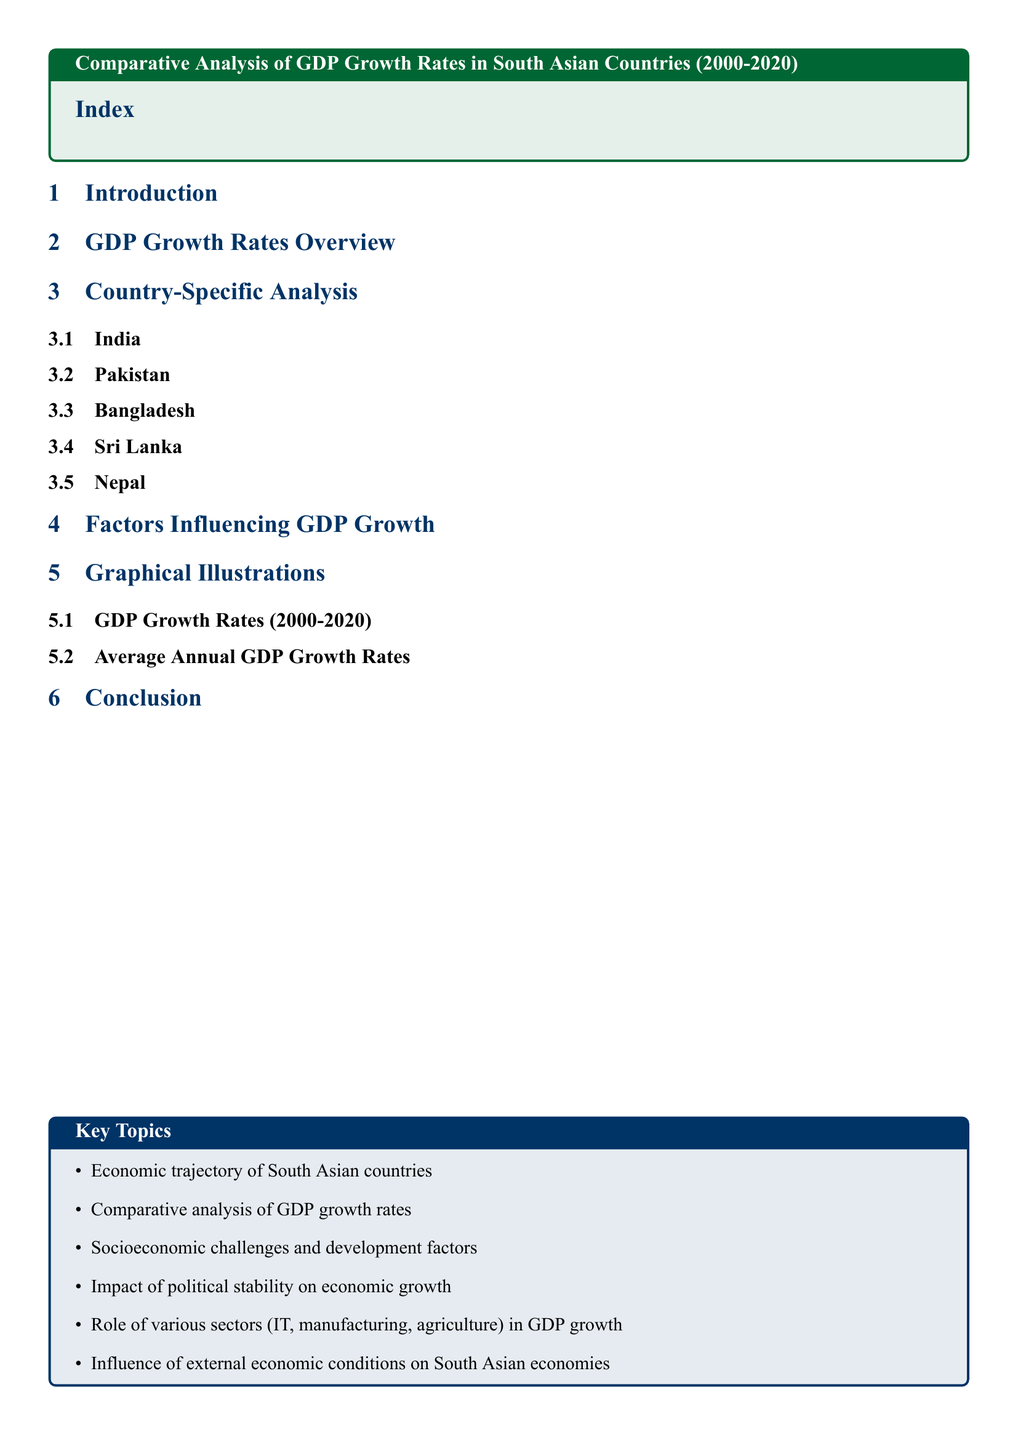What years are covered in the GDP analysis? The document analyzes GDP growth rates from the years 2000 to 2020.
Answer: 2000-2020 How many countries are specifically analyzed in the document? The document specifies the GDP growth analysis for five countries in South Asia.
Answer: Five Which country has its own subsection in the analysis? The document includes individual subsections for multiple countries, such as India, which is one of them.
Answer: India What is one of the key topics mentioned in the document? The document lists key topics at the end, one of which is "Comparison of GDP growth rates."
Answer: Comparison of GDP growth rates What section discusses the factors influencing GDP growth? The section titled "Factors Influencing GDP Growth" addresses this topic specifically.
Answer: Factors Influencing GDP Growth Which visual illustration is included in the document? The document features graphical illustrations like "GDP Growth Rates (2000-2020)."
Answer: GDP Growth Rates (2000-2020) What is the focus of the conclusion section? The conclusion section summarizes findings and insights from the document, reflecting on the overall analysis.
Answer: Overall analysis What is the color coding for the introduction section? The introduction section's color code is not explicitly stated in the document, but it follows the overall theme.
Answer: Theme colors What does the document analyze alongside GDP growth rates? The document examines economic conditions and challenges alongside the GDP growth analysis.
Answer: Economic conditions and challenges 